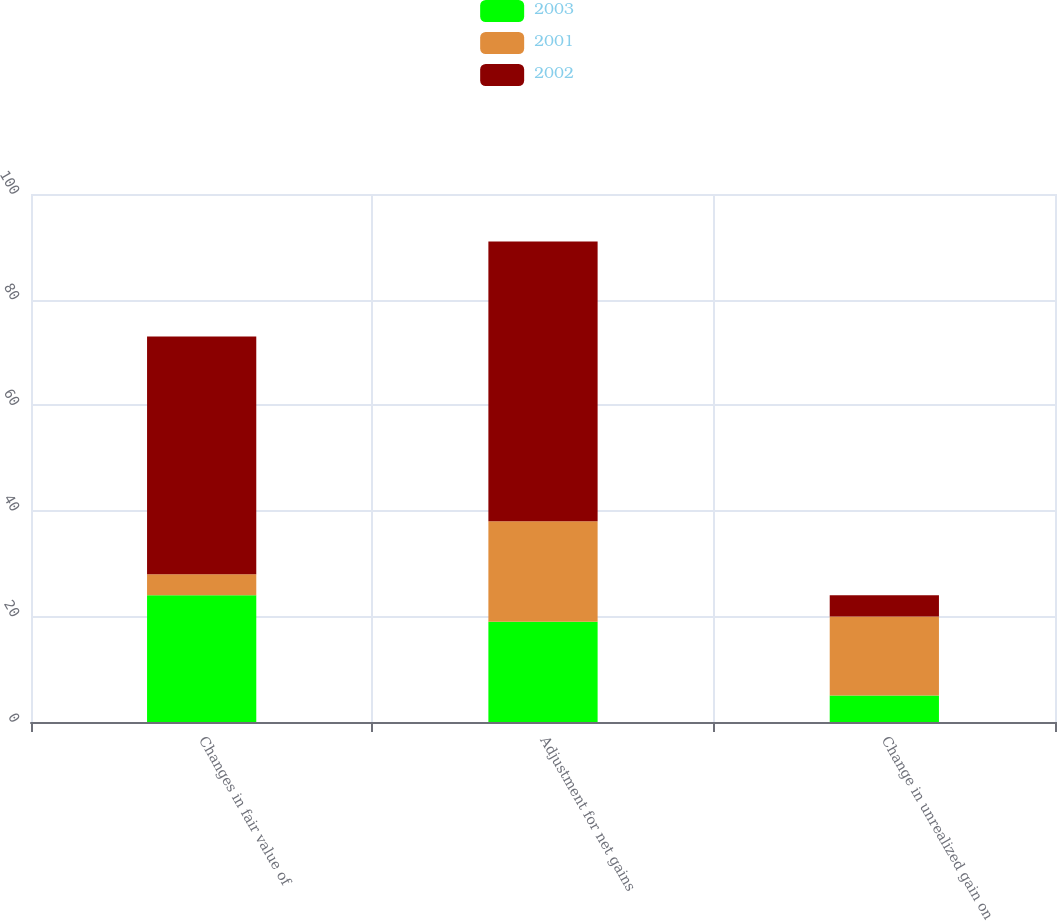<chart> <loc_0><loc_0><loc_500><loc_500><stacked_bar_chart><ecel><fcel>Changes in fair value of<fcel>Adjustment for net gains<fcel>Change in unrealized gain on<nl><fcel>2003<fcel>24<fcel>19<fcel>5<nl><fcel>2001<fcel>4<fcel>19<fcel>15<nl><fcel>2002<fcel>45<fcel>53<fcel>4<nl></chart> 